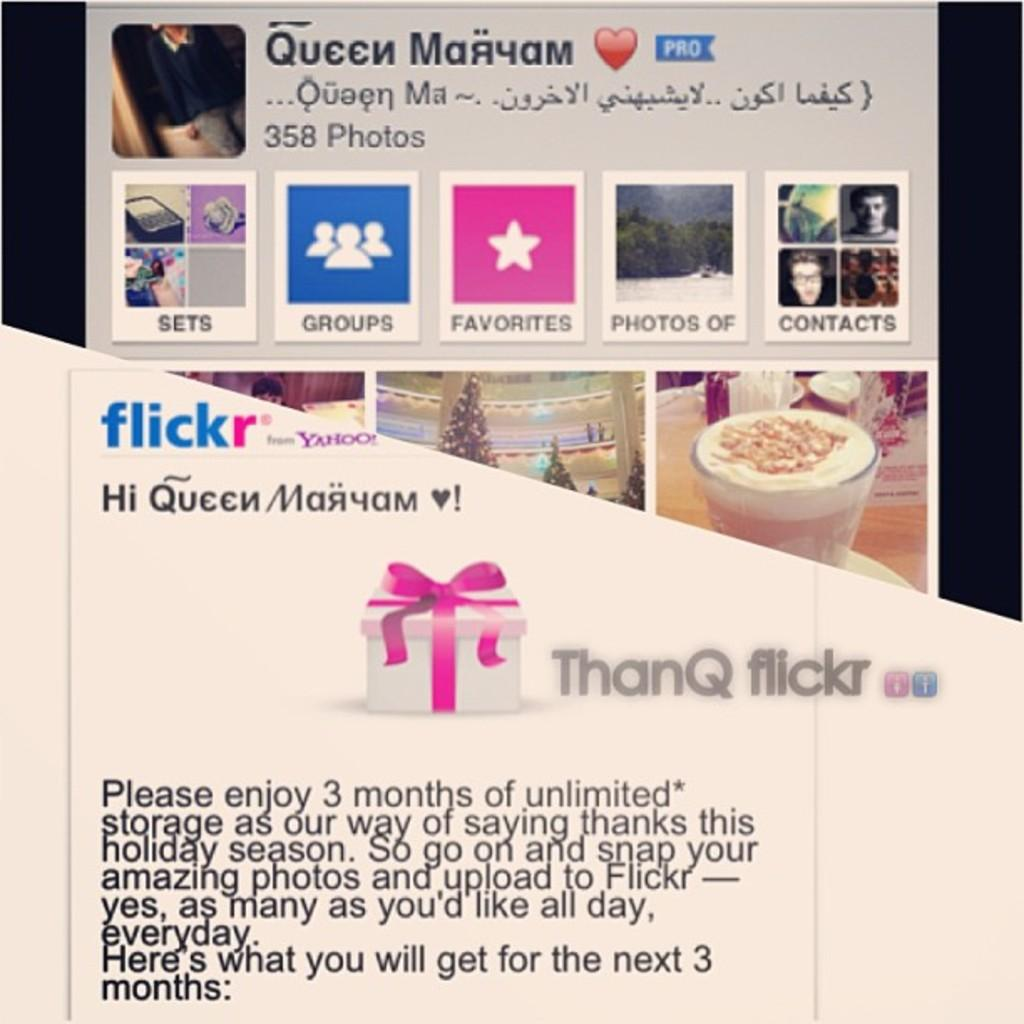What can be seen in the image related to a visual display? There is a poster in the image. What is featured on the poster? There is text written on the poster. Can you see any farmer's toes in the image? There is no farmer or toes present in the image; it only features a poster with text. 